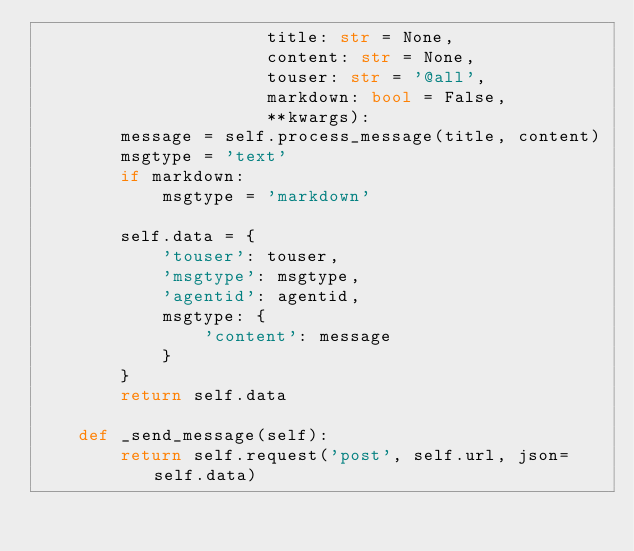Convert code to text. <code><loc_0><loc_0><loc_500><loc_500><_Python_>                      title: str = None,
                      content: str = None,
                      touser: str = '@all',
                      markdown: bool = False,
                      **kwargs):
        message = self.process_message(title, content)
        msgtype = 'text'
        if markdown:
            msgtype = 'markdown'

        self.data = {
            'touser': touser,
            'msgtype': msgtype,
            'agentid': agentid,
            msgtype: {
                'content': message
            }
        }
        return self.data

    def _send_message(self):
        return self.request('post', self.url, json=self.data)
</code> 